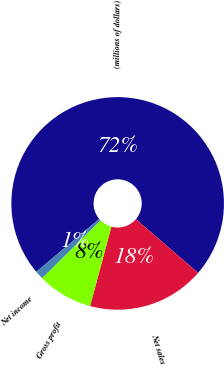<chart> <loc_0><loc_0><loc_500><loc_500><pie_chart><fcel>(millions of dollars)<fcel>Net sales<fcel>Gross profit<fcel>Net income<nl><fcel>72.46%<fcel>17.84%<fcel>8.41%<fcel>1.29%<nl></chart> 